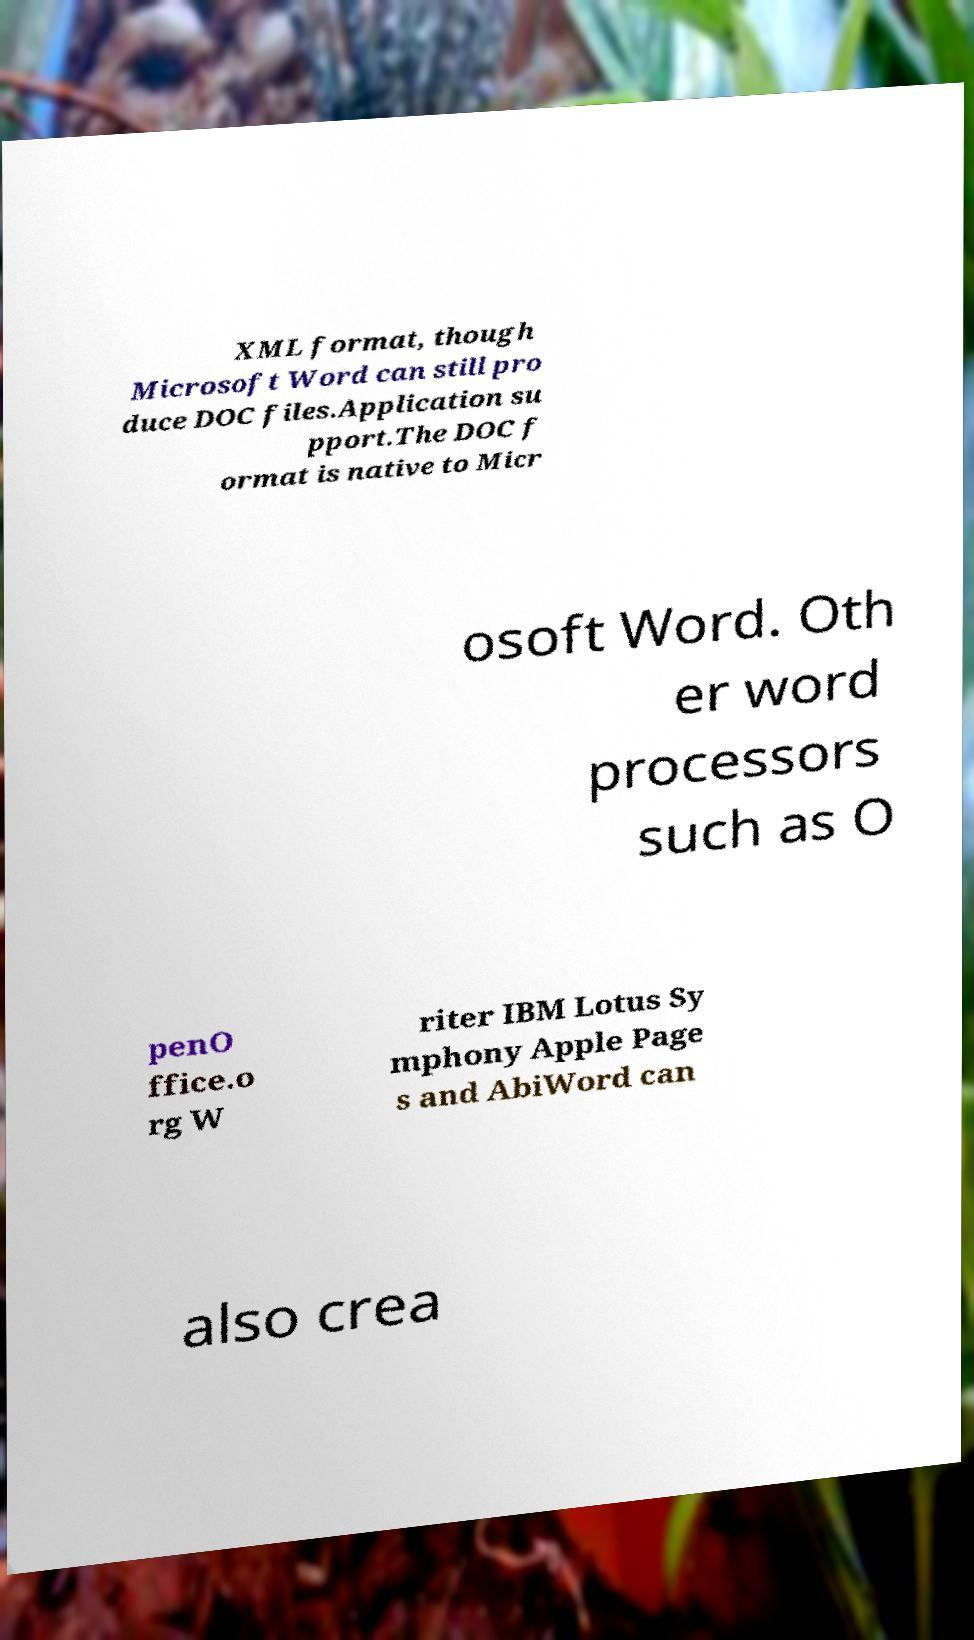Could you assist in decoding the text presented in this image and type it out clearly? XML format, though Microsoft Word can still pro duce DOC files.Application su pport.The DOC f ormat is native to Micr osoft Word. Oth er word processors such as O penO ffice.o rg W riter IBM Lotus Sy mphony Apple Page s and AbiWord can also crea 